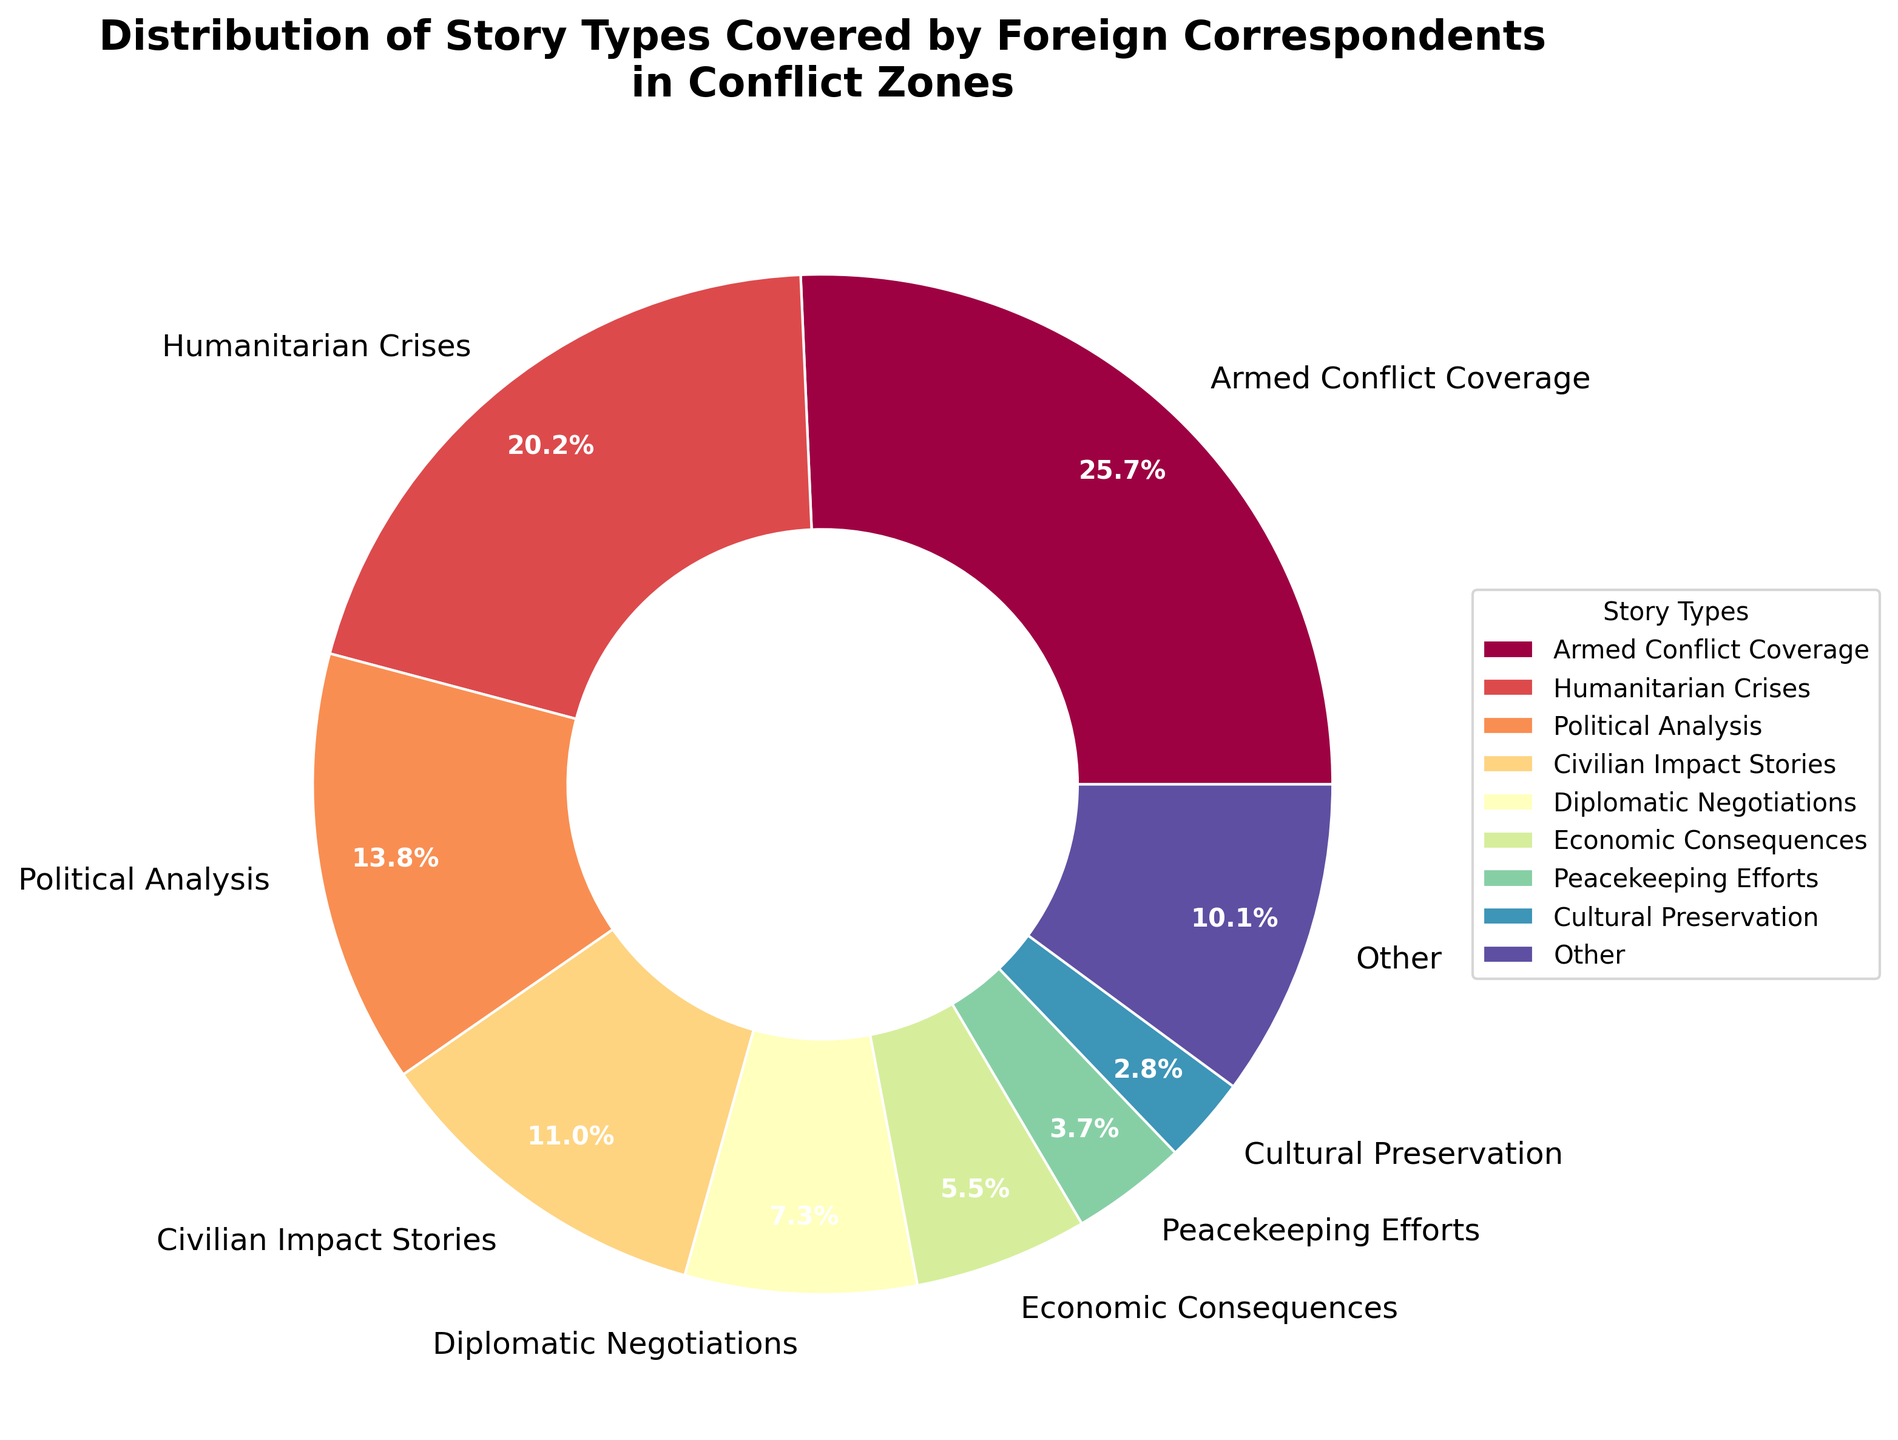What percentage of stories cover both Economic Consequences and Post-Conflict Reconstruction combined? To find the combined percentage for Economic Consequences and Post-Conflict Reconstruction, add their individual percentages from the chart: 6% (Economic Consequences) + 1% (Post-Conflict Reconstruction).
Answer: 7% Which story type appears to be the third most covered topic by foreign correspondents in conflict zones? Identify the one with the third highest percentage from the chart. Armed Conflict Coverage (28%) is the first, Humanitarian Crises (22%) is the second, and Political Analysis (15%) is the third.
Answer: Political Analysis Is the percentage of Media Freedom Issues stories greater than or equal to the percentage of Technological Warfare stories? Compare the values of the two categories from the chart: Media Freedom Issues (1%) and Technological Warfare (1%). Since they are equal, the answer is yes.
Answer: Yes What is the combined percentage of the story types labeled as "Other"? Identify the story types under 3%: Cultural Preservation (3%), Environmental Impact (2%), Medical Aid Operations (2%), Refugee Narratives (2%), War Crime Investigations (2%), Technological Warfare (1%), Post-Conflict Reconstruction (1%), Media Freedom Issues (1%). Sum these percentages: 2% + 2% + 2% + 1% + 1% + 1% = 9%.
Answer: 9% Which two story types have the same percentage and what is the percentage? Look for categories with the same percentage in the chart. Both Medical Aid Operations and Refugee Narratives are at 2%.
Answer: Medical Aid Operations and Refugee Narratives, 2% How does the percentage of Diplomatic Negotiations compare to Peacekeeping Efforts? Identify and compare the percentages from the chart: Diplomatic Negotiations (8%) and Peacekeeping Efforts (4%). Diplomatic Negotiations is higher.
Answer: Diplomatic Negotiations is higher What is the sum of percentages for stories focusing on Peacekeeping Efforts, Environmental Impact, and War Crime Investigations? Add the percentages from the chart: Peacekeeping Efforts (4%), Environmental Impact (2%), War Crime Investigations (2%). So, 4% + 2% + 2% = 8%.
Answer: 8% Which story type has the lowest coverage according to the chart? Identify the category with the lowest percentage from the chart, which is Technological Warfare, Post-Conflict Reconstruction, and Media Freedom Issues all with 1%.
Answer: Technological Warfare, Post-Conflict Reconstruction, and Media Freedom Issues 